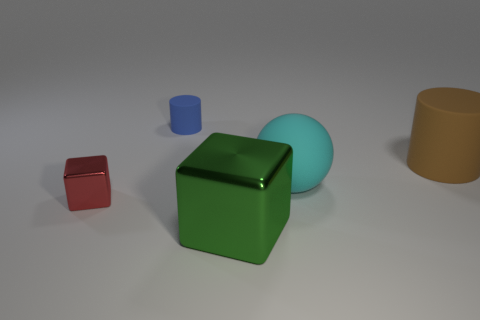Add 1 gray cylinders. How many objects exist? 6 Subtract all cylinders. How many objects are left? 3 Add 2 big blue matte cylinders. How many big blue matte cylinders exist? 2 Subtract 0 blue blocks. How many objects are left? 5 Subtract all big red shiny cylinders. Subtract all small matte things. How many objects are left? 4 Add 1 green metal blocks. How many green metal blocks are left? 2 